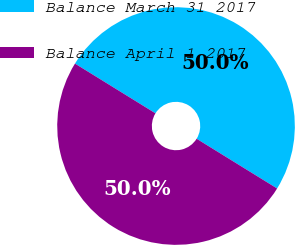Convert chart. <chart><loc_0><loc_0><loc_500><loc_500><pie_chart><fcel>Balance March 31 2017<fcel>Balance April 1 2017<nl><fcel>50.0%<fcel>50.0%<nl></chart> 